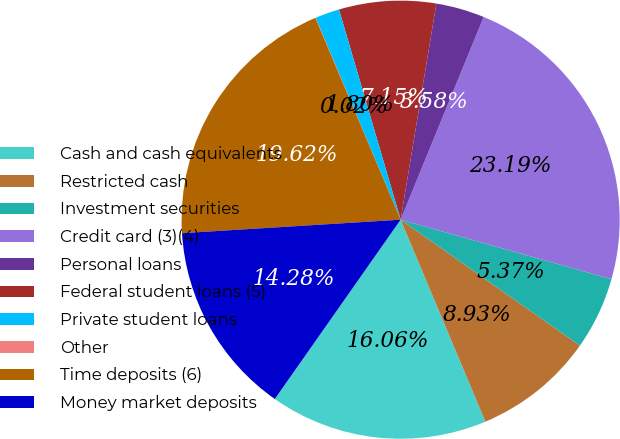<chart> <loc_0><loc_0><loc_500><loc_500><pie_chart><fcel>Cash and cash equivalents<fcel>Restricted cash<fcel>Investment securities<fcel>Credit card (3)(4)<fcel>Personal loans<fcel>Federal student loans (5)<fcel>Private student loans<fcel>Other<fcel>Time deposits (6)<fcel>Money market deposits<nl><fcel>16.06%<fcel>8.93%<fcel>5.37%<fcel>23.19%<fcel>3.58%<fcel>7.15%<fcel>1.8%<fcel>0.02%<fcel>19.62%<fcel>14.28%<nl></chart> 